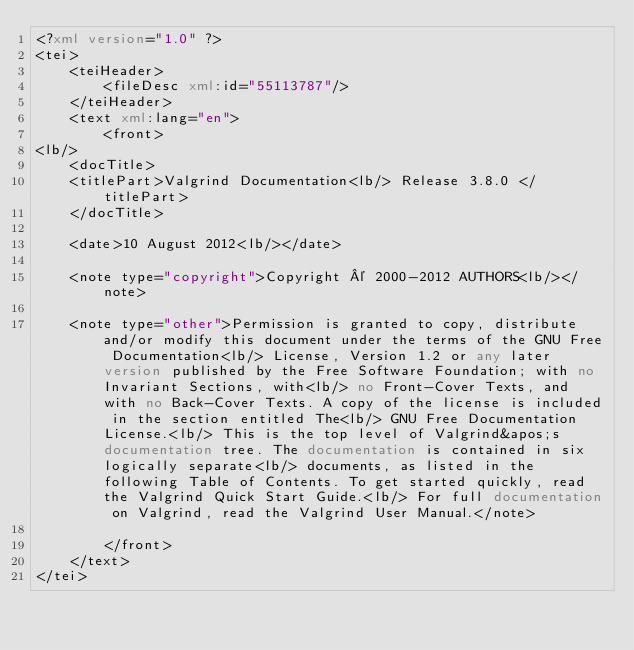<code> <loc_0><loc_0><loc_500><loc_500><_XML_><?xml version="1.0" ?>
<tei>
	<teiHeader>
		<fileDesc xml:id="55113787"/>
	</teiHeader>
	<text xml:lang="en">
		<front>
<lb/>
	<docTitle>
	<titlePart>Valgrind Documentation<lb/> Release 3.8.0 </titlePart>
	</docTitle>

	<date>10 August 2012<lb/></date>

	<note type="copyright">Copyright © 2000-2012 AUTHORS<lb/></note>

	<note type="other">Permission is granted to copy, distribute and/or modify this document under the terms of the GNU Free Documentation<lb/> License, Version 1.2 or any later version published by the Free Software Foundation; with no Invariant Sections, with<lb/> no Front-Cover Texts, and with no Back-Cover Texts. A copy of the license is included in the section entitled The<lb/> GNU Free Documentation License.<lb/> This is the top level of Valgrind&apos;s documentation tree. The documentation is contained in six logically separate<lb/> documents, as listed in the following Table of Contents. To get started quickly, read the Valgrind Quick Start Guide.<lb/> For full documentation on Valgrind, read the Valgrind User Manual.</note>

		</front>
	</text>
</tei>
</code> 